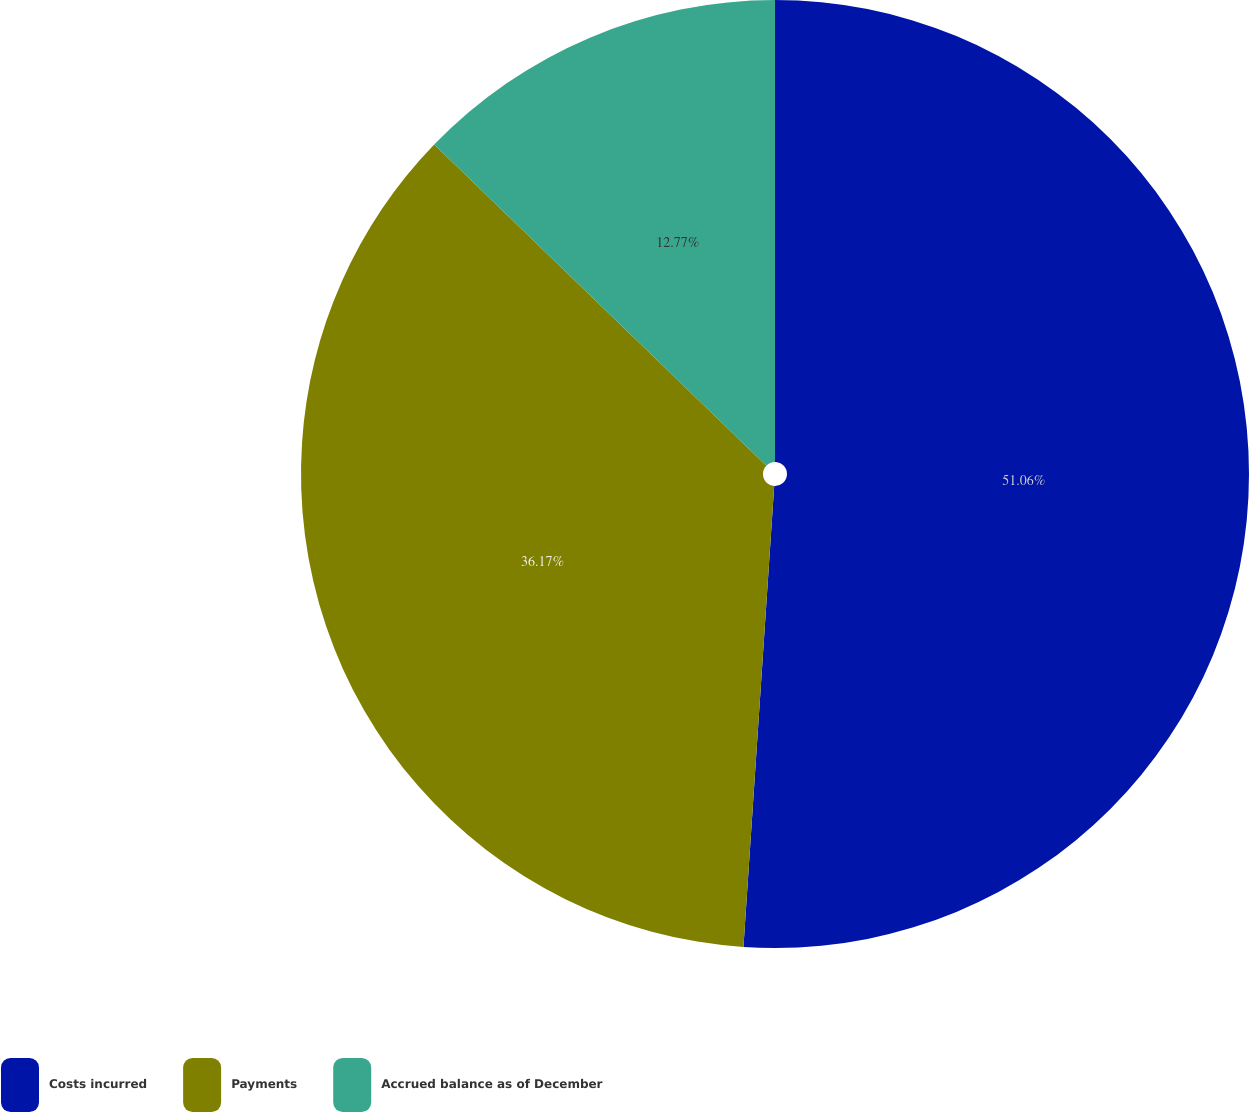Convert chart. <chart><loc_0><loc_0><loc_500><loc_500><pie_chart><fcel>Costs incurred<fcel>Payments<fcel>Accrued balance as of December<nl><fcel>51.06%<fcel>36.17%<fcel>12.77%<nl></chart> 